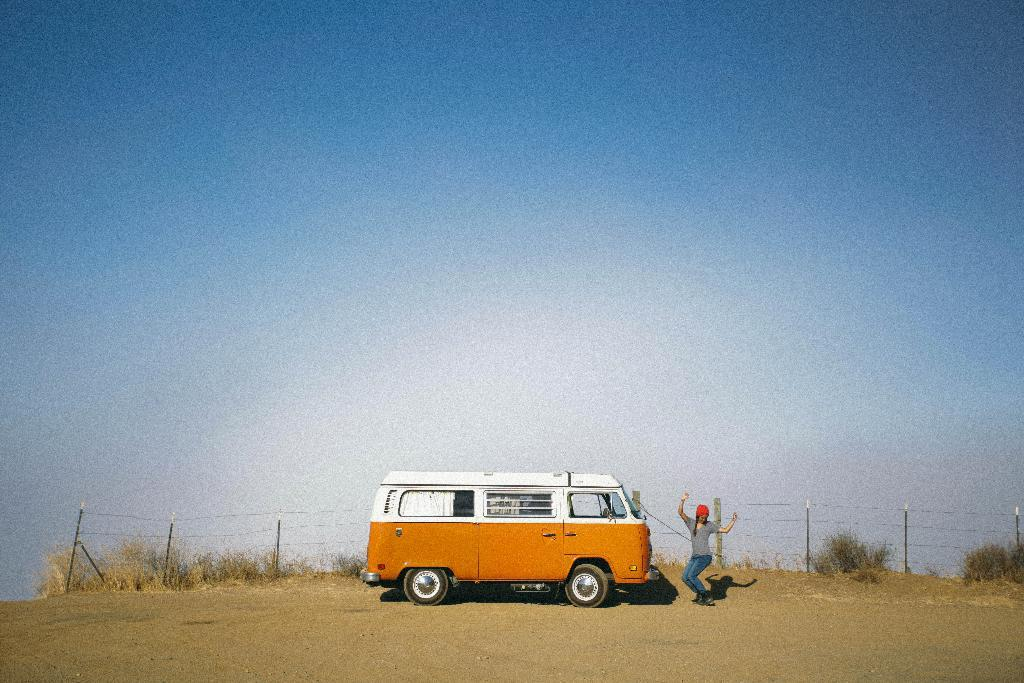What type of motor vehicle is in the image? The type of motor vehicle is not specified in the facts. What is the woman doing in the image? The woman is standing on the road in the image. What type of vegetation can be seen in the background of the image? Shrubs and bushes are visible in the background of the image. What is the condition of the sky in the image? The sky is visible in the background of the image, and there are clouds present. What architectural feature is in the background of the image? There is an iron fence in the background of the image. How many cattle are grazing in the middle of the image? There are no cattle present in the image. What type of mailbox is located near the woman in the image? There is no mailbox mentioned or visible in the image. 